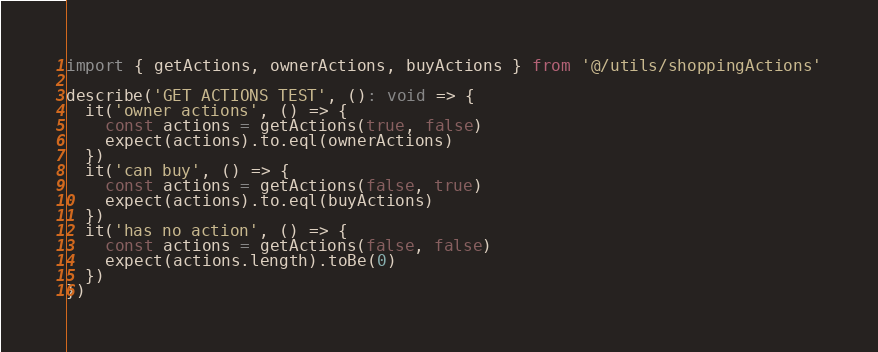Convert code to text. <code><loc_0><loc_0><loc_500><loc_500><_TypeScript_>import { getActions, ownerActions, buyActions } from '@/utils/shoppingActions'

describe('GET ACTIONS TEST', (): void => {
  it('owner actions', () => {
    const actions = getActions(true, false)
    expect(actions).to.eql(ownerActions)
  })
  it('can buy', () => {
    const actions = getActions(false, true)
    expect(actions).to.eql(buyActions)
  })
  it('has no action', () => {
    const actions = getActions(false, false)
    expect(actions.length).toBe(0)
  })
})
</code> 